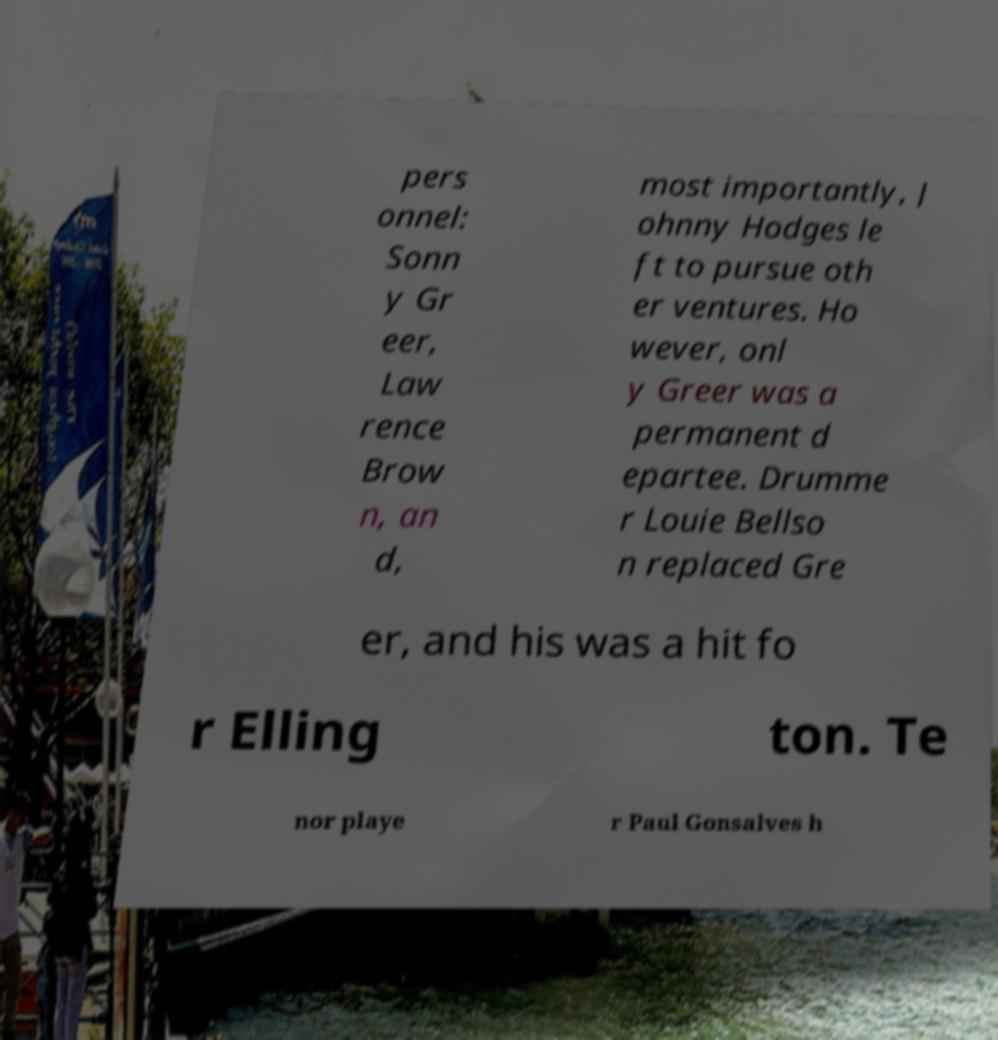Please read and relay the text visible in this image. What does it say? pers onnel: Sonn y Gr eer, Law rence Brow n, an d, most importantly, J ohnny Hodges le ft to pursue oth er ventures. Ho wever, onl y Greer was a permanent d epartee. Drumme r Louie Bellso n replaced Gre er, and his was a hit fo r Elling ton. Te nor playe r Paul Gonsalves h 